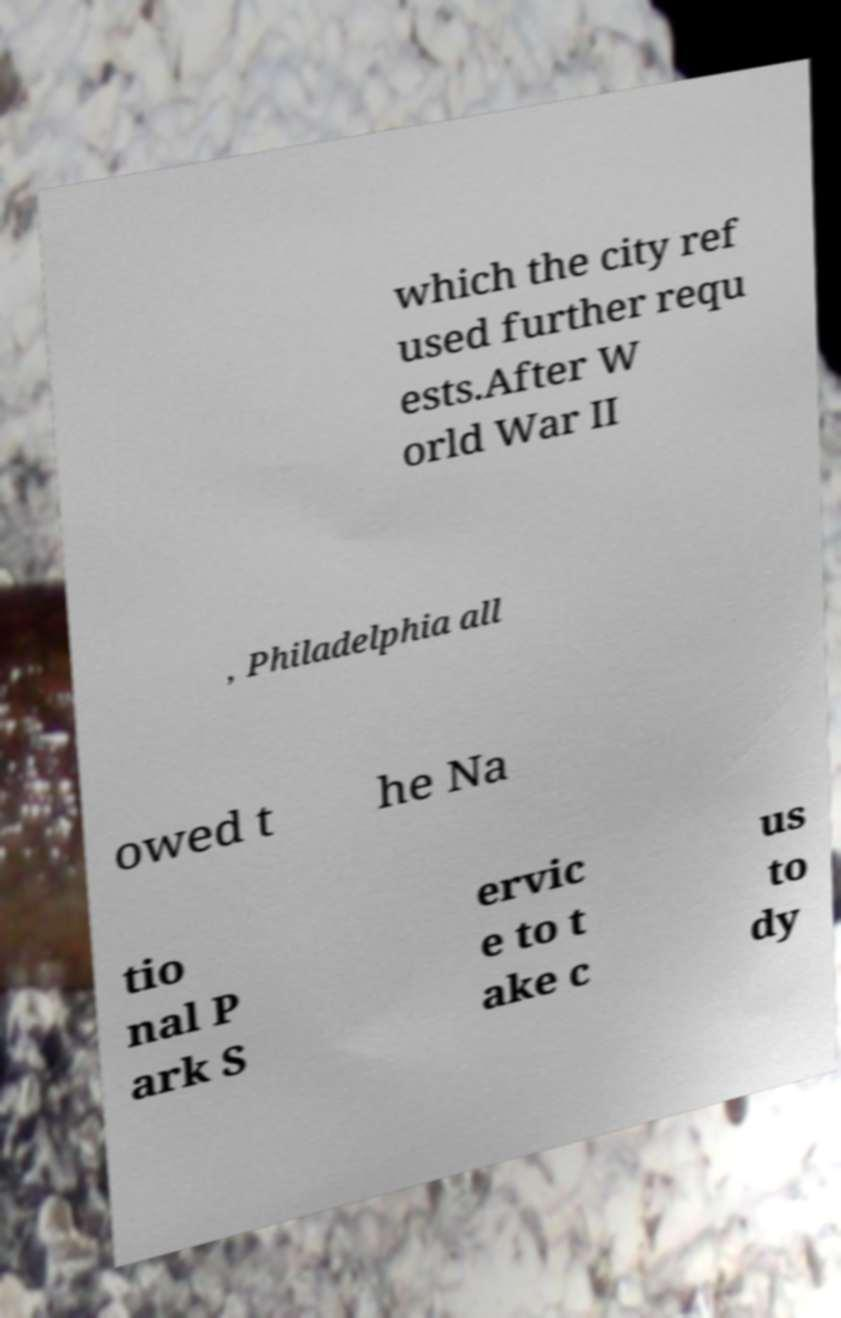I need the written content from this picture converted into text. Can you do that? which the city ref used further requ ests.After W orld War II , Philadelphia all owed t he Na tio nal P ark S ervic e to t ake c us to dy 